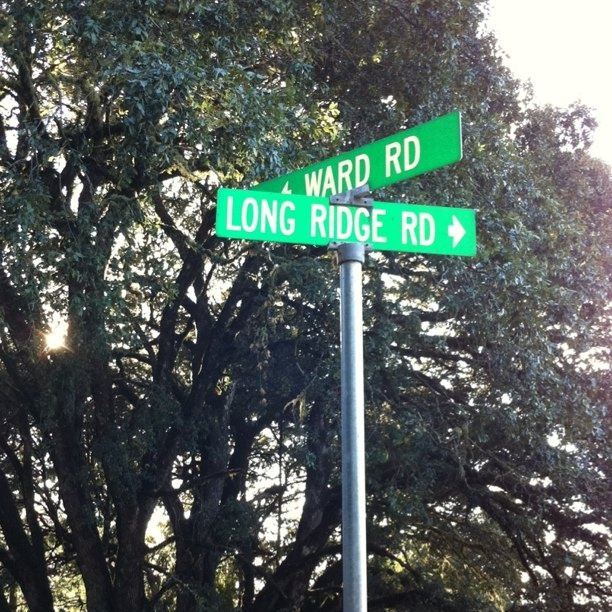Describe the objects in this image and their specific colors. I can see various objects in this image with different colors. 